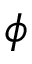Convert formula to latex. <formula><loc_0><loc_0><loc_500><loc_500>\phi</formula> 